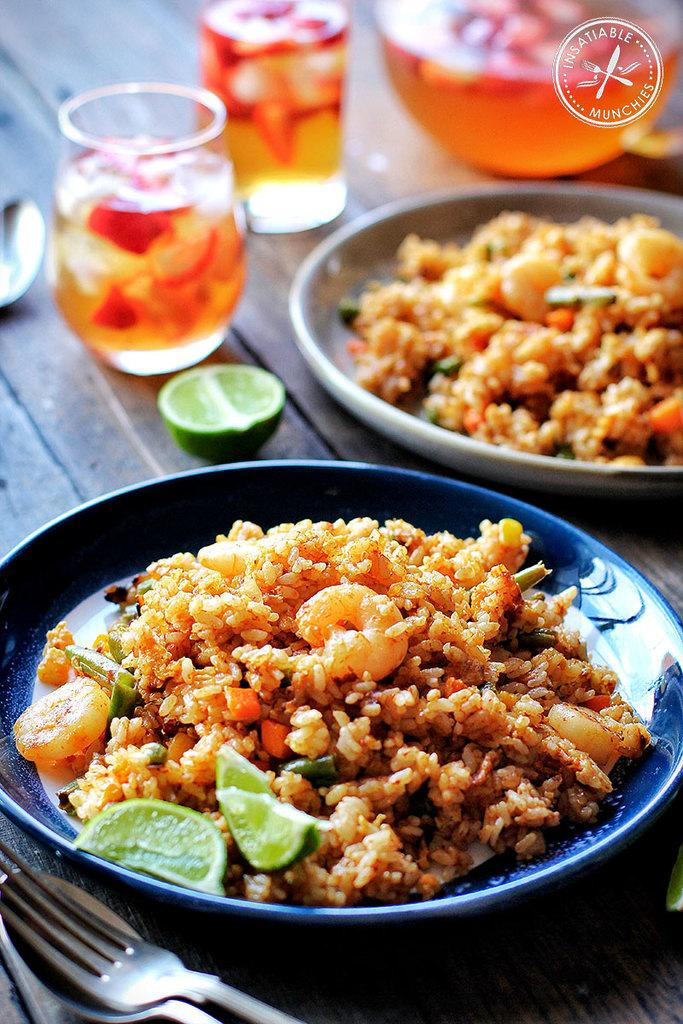What types of food or drink containers are visible in the image? There are different dishes and glasses in the image. What else can be seen in the image besides containers? There is a jar, spoons, and lemons in the image. What is the surface on which the objects are placed? The objects are placed on a wooden table. What type of drug is being stored in the jar in the image? There is no drug present in the image; the jar contains lemons. What type of shirt is being worn by the person in the image? There is no person present in the image, so it is not possible to determine what type of shirt they might be wearing. 